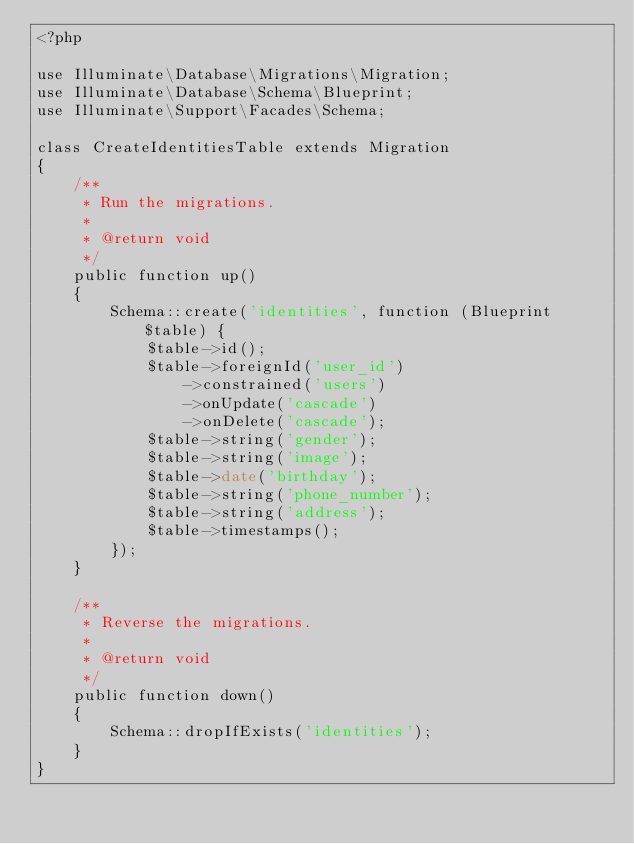<code> <loc_0><loc_0><loc_500><loc_500><_PHP_><?php

use Illuminate\Database\Migrations\Migration;
use Illuminate\Database\Schema\Blueprint;
use Illuminate\Support\Facades\Schema;

class CreateIdentitiesTable extends Migration
{
    /**
     * Run the migrations.
     *
     * @return void
     */
    public function up()
    {
        Schema::create('identities', function (Blueprint $table) {
            $table->id();
            $table->foreignId('user_id')
                ->constrained('users')
                ->onUpdate('cascade')
                ->onDelete('cascade');
            $table->string('gender');
            $table->string('image');
            $table->date('birthday');
            $table->string('phone_number');
            $table->string('address');
            $table->timestamps();
        });
    }

    /**
     * Reverse the migrations.
     *
     * @return void
     */
    public function down()
    {
        Schema::dropIfExists('identities');
    }
}
</code> 